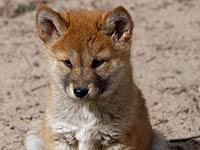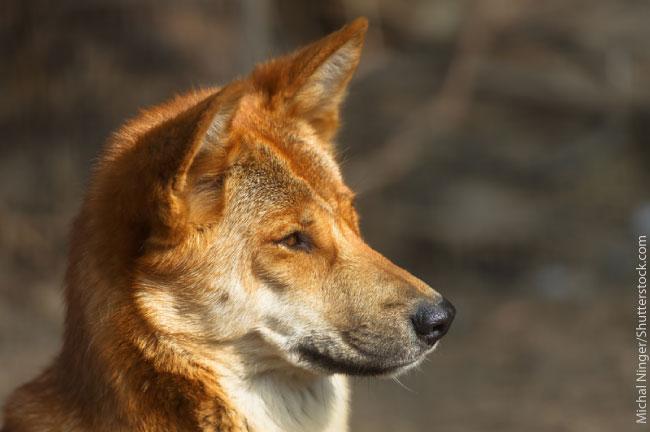The first image is the image on the left, the second image is the image on the right. For the images shown, is this caption "The left image features a dingo reclining with upright head, and all dingos shown are adults." true? Answer yes or no. No. The first image is the image on the left, the second image is the image on the right. For the images displayed, is the sentence "there is a canine lying down in the image to the left" factually correct? Answer yes or no. No. 